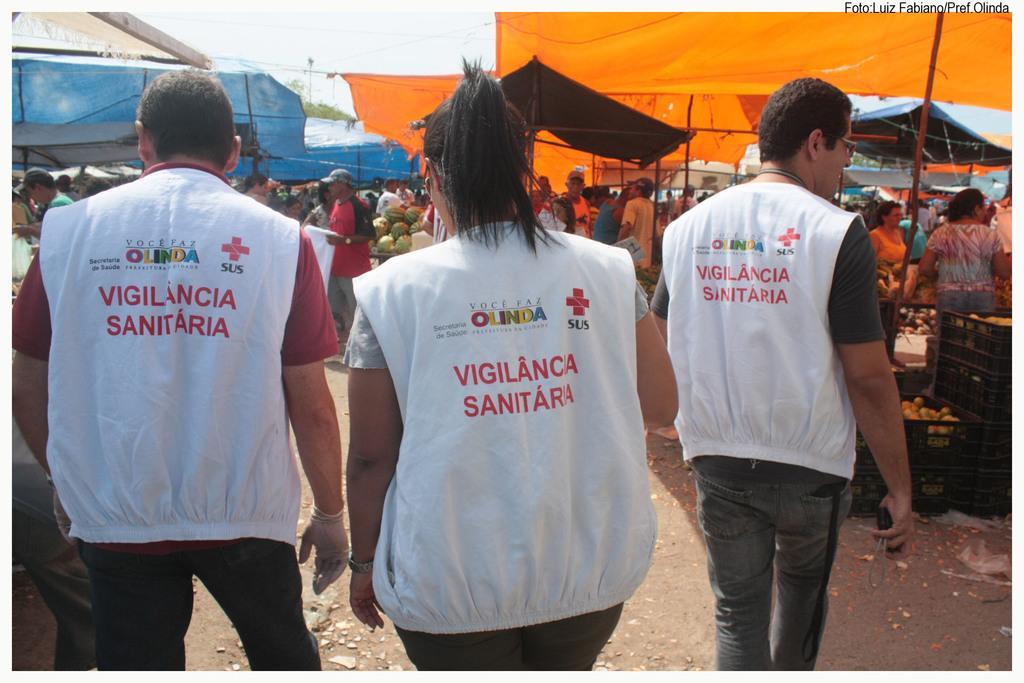Describe this image in one or two sentences. This picture shows few people walking, They wore jackets and we see few people standing and we see tents. Picture Looks like a market. We see few of them wore caps on their heads and a electrical pole and a cloudy sky. 